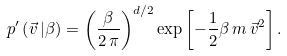<formula> <loc_0><loc_0><loc_500><loc_500>p ^ { \prime } \left ( \vec { v } \, | \beta \right ) = \left ( \frac { \beta } { 2 \, \pi } \right ) ^ { d / 2 } \exp \left [ - \frac { 1 } { 2 } \beta \, m \, \vec { v } ^ { 2 } \right ] .</formula> 